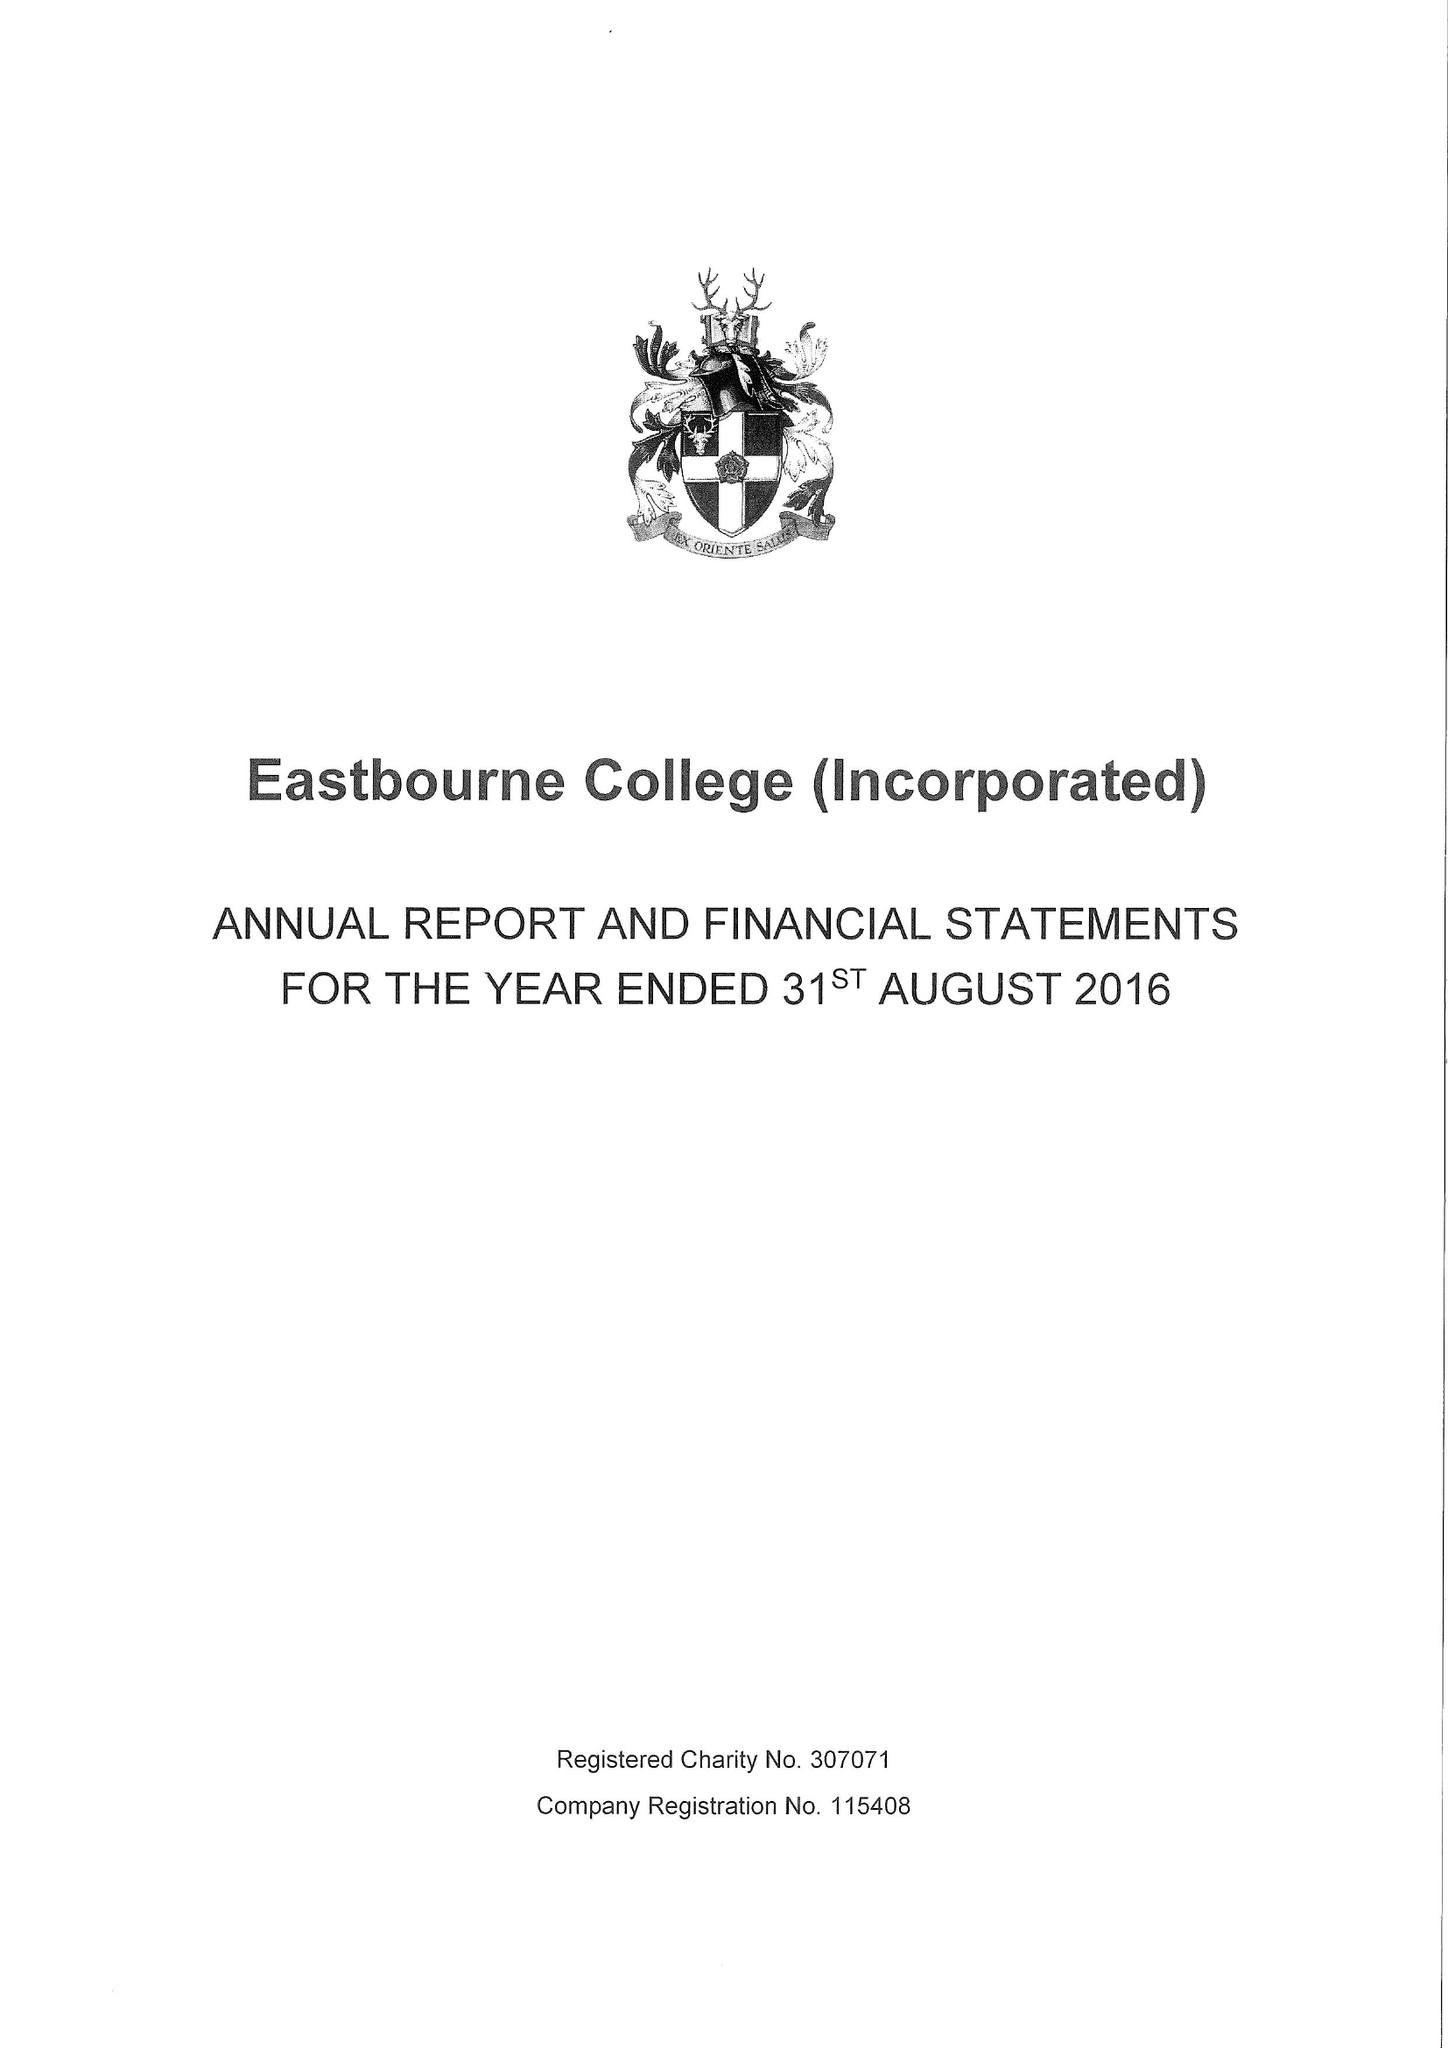What is the value for the charity_name?
Answer the question using a single word or phrase. Eastbourne College (Incorporated) 